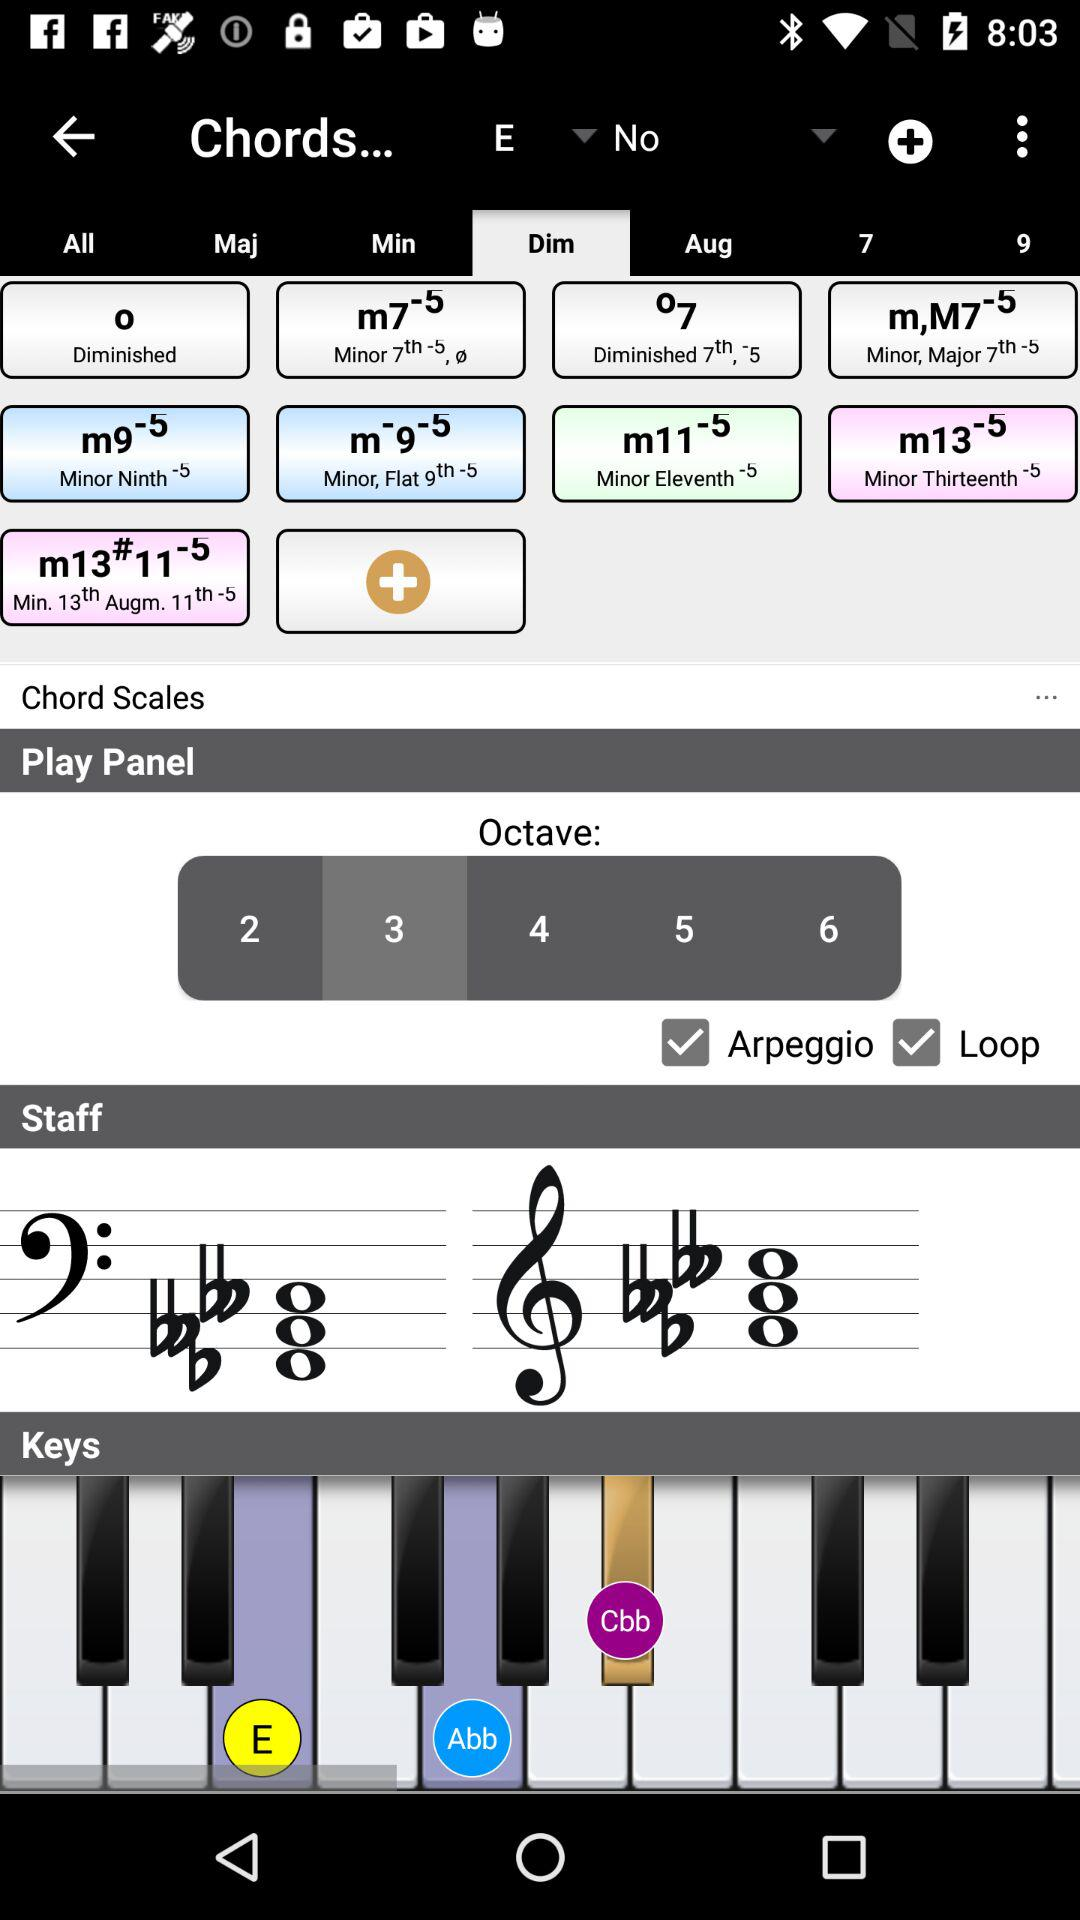What is the chord scale on the play panel? The chord scale is 3. 